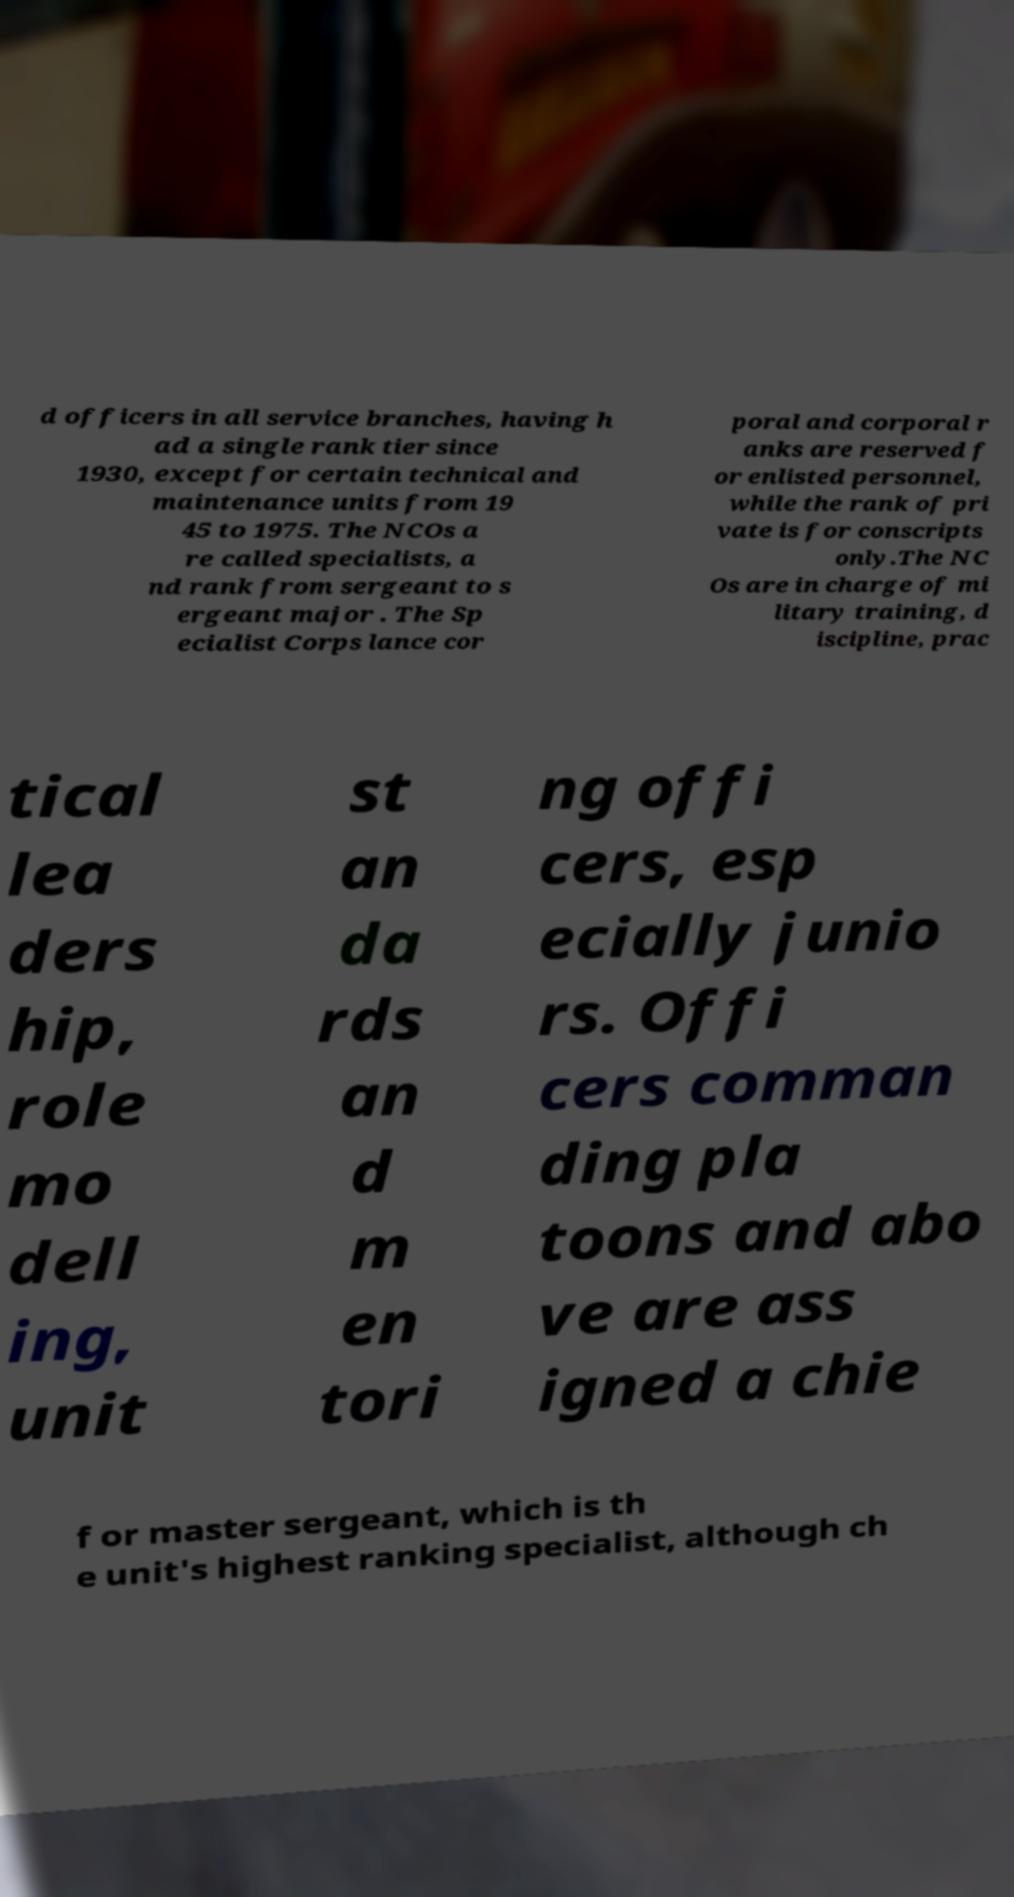I need the written content from this picture converted into text. Can you do that? d officers in all service branches, having h ad a single rank tier since 1930, except for certain technical and maintenance units from 19 45 to 1975. The NCOs a re called specialists, a nd rank from sergeant to s ergeant major . The Sp ecialist Corps lance cor poral and corporal r anks are reserved f or enlisted personnel, while the rank of pri vate is for conscripts only.The NC Os are in charge of mi litary training, d iscipline, prac tical lea ders hip, role mo dell ing, unit st an da rds an d m en tori ng offi cers, esp ecially junio rs. Offi cers comman ding pla toons and abo ve are ass igned a chie f or master sergeant, which is th e unit's highest ranking specialist, although ch 